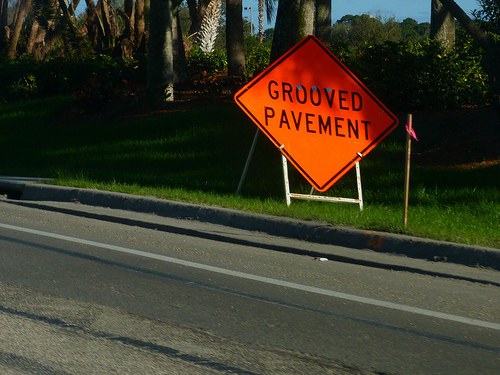<image>
Is the tree behind the sign? Yes. From this viewpoint, the tree is positioned behind the sign, with the sign partially or fully occluding the tree. 